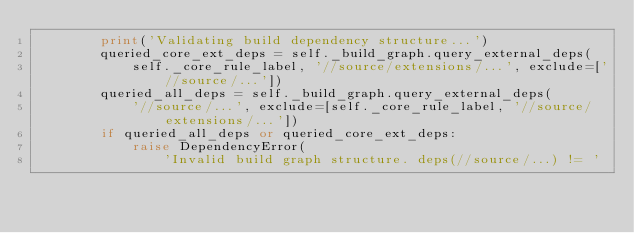<code> <loc_0><loc_0><loc_500><loc_500><_Python_>        print('Validating build dependency structure...')
        queried_core_ext_deps = self._build_graph.query_external_deps(
            self._core_rule_label, '//source/extensions/...', exclude=['//source/...'])
        queried_all_deps = self._build_graph.query_external_deps(
            '//source/...', exclude=[self._core_rule_label, '//source/extensions/...'])
        if queried_all_deps or queried_core_ext_deps:
            raise DependencyError(
                'Invalid build graph structure. deps(//source/...) != '</code> 